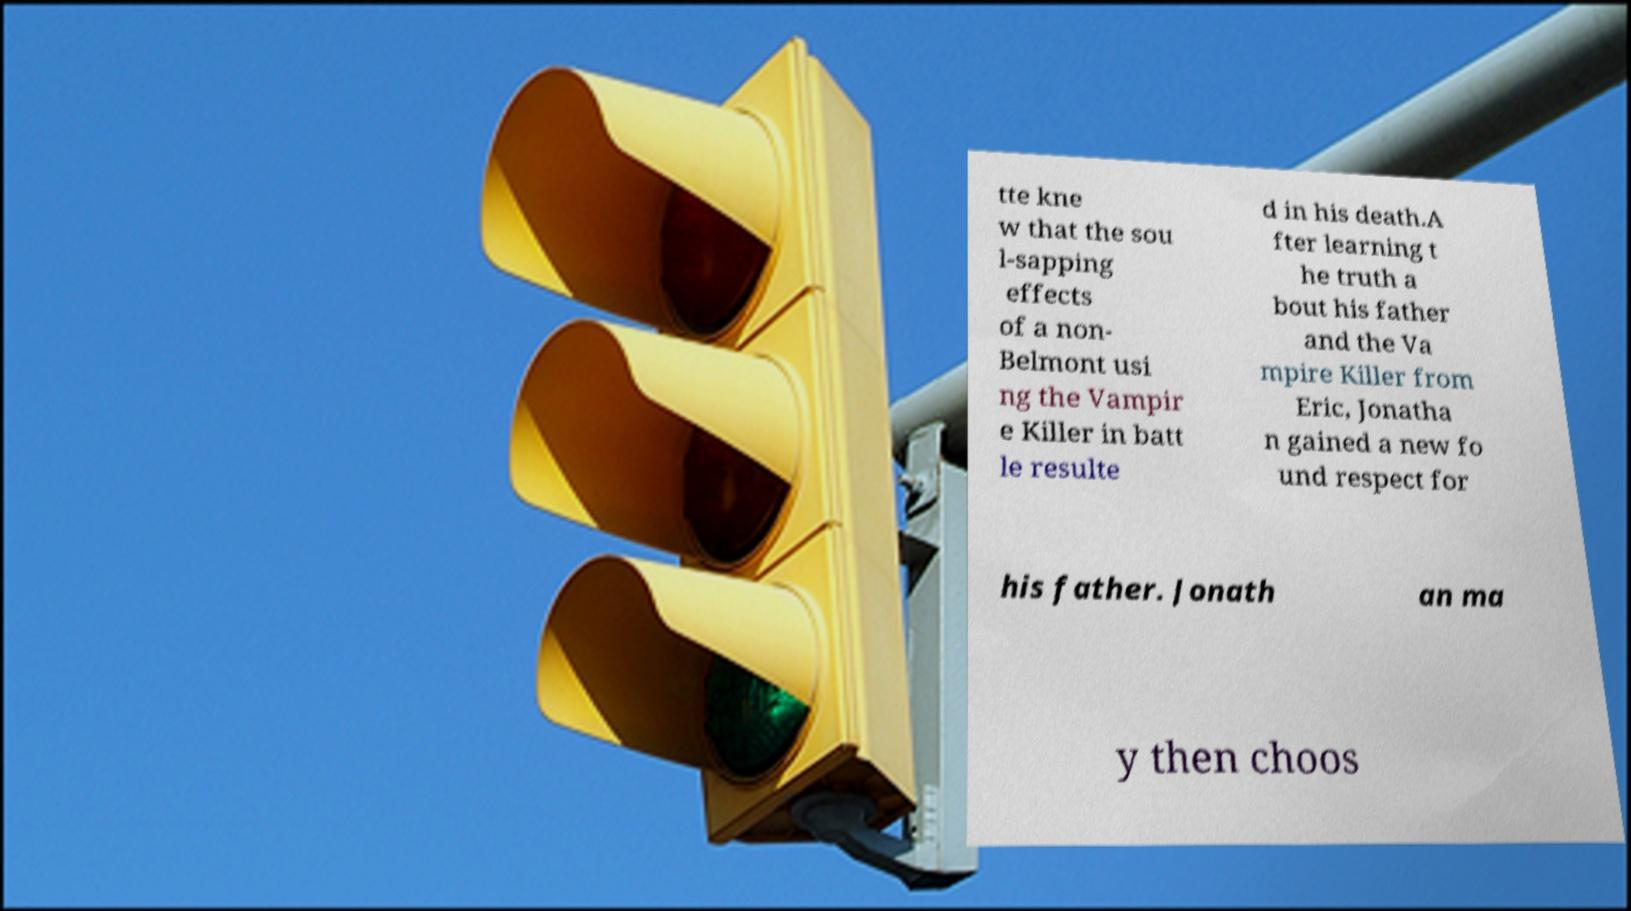What messages or text are displayed in this image? I need them in a readable, typed format. tte kne w that the sou l-sapping effects of a non- Belmont usi ng the Vampir e Killer in batt le resulte d in his death.A fter learning t he truth a bout his father and the Va mpire Killer from Eric, Jonatha n gained a new fo und respect for his father. Jonath an ma y then choos 